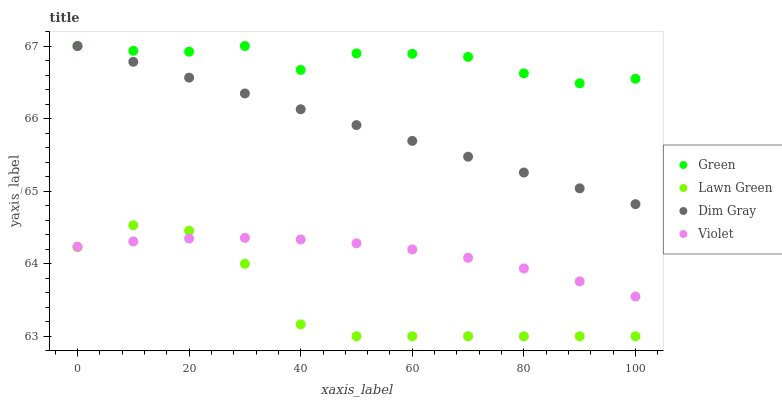Does Lawn Green have the minimum area under the curve?
Answer yes or no. Yes. Does Green have the maximum area under the curve?
Answer yes or no. Yes. Does Dim Gray have the minimum area under the curve?
Answer yes or no. No. Does Dim Gray have the maximum area under the curve?
Answer yes or no. No. Is Dim Gray the smoothest?
Answer yes or no. Yes. Is Lawn Green the roughest?
Answer yes or no. Yes. Is Green the smoothest?
Answer yes or no. No. Is Green the roughest?
Answer yes or no. No. Does Lawn Green have the lowest value?
Answer yes or no. Yes. Does Dim Gray have the lowest value?
Answer yes or no. No. Does Green have the highest value?
Answer yes or no. Yes. Does Violet have the highest value?
Answer yes or no. No. Is Violet less than Green?
Answer yes or no. Yes. Is Green greater than Violet?
Answer yes or no. Yes. Does Green intersect Dim Gray?
Answer yes or no. Yes. Is Green less than Dim Gray?
Answer yes or no. No. Is Green greater than Dim Gray?
Answer yes or no. No. Does Violet intersect Green?
Answer yes or no. No. 